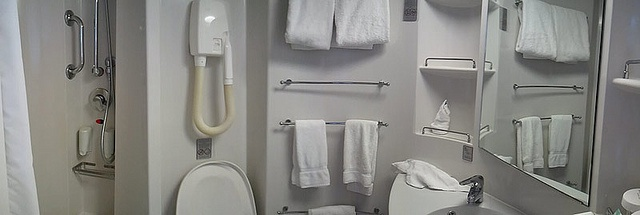Describe the objects in this image and their specific colors. I can see hair drier in darkgray and gray tones, toilet in darkgray, gray, and lightgray tones, and sink in darkgray, gray, and black tones in this image. 